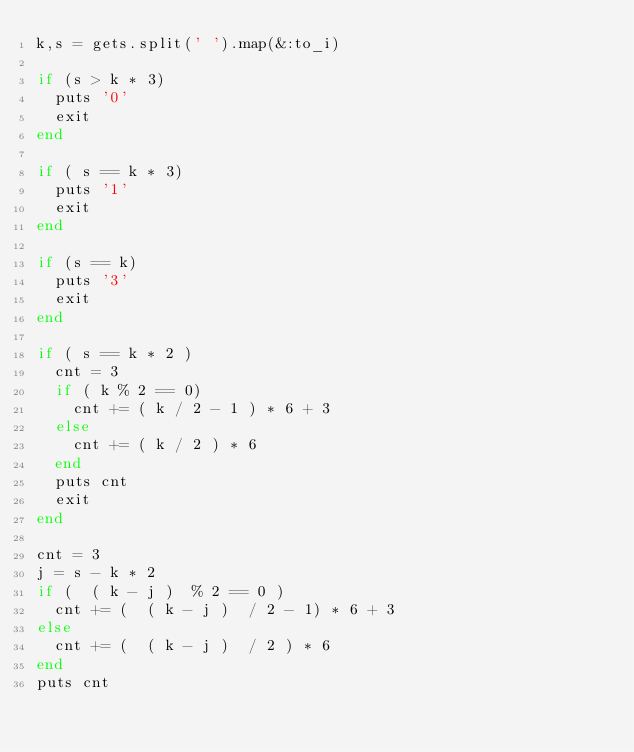<code> <loc_0><loc_0><loc_500><loc_500><_Ruby_>k,s = gets.split(' ').map(&:to_i)

if (s > k * 3)
  puts '0'
  exit
end

if ( s == k * 3)
  puts '1'
  exit
end

if (s == k)
  puts '3'
  exit
end

if ( s == k * 2 )
  cnt = 3
  if ( k % 2 == 0)
    cnt += ( k / 2 - 1 ) * 6 + 3
  else
    cnt += ( k / 2 ) * 6
  end
  puts cnt
  exit
end

cnt = 3
j = s - k * 2
if (  ( k - j )  % 2 == 0 )
  cnt += (  ( k - j )  / 2 - 1) * 6 + 3
else
  cnt += (  ( k - j )  / 2 ) * 6
end
puts cnt</code> 